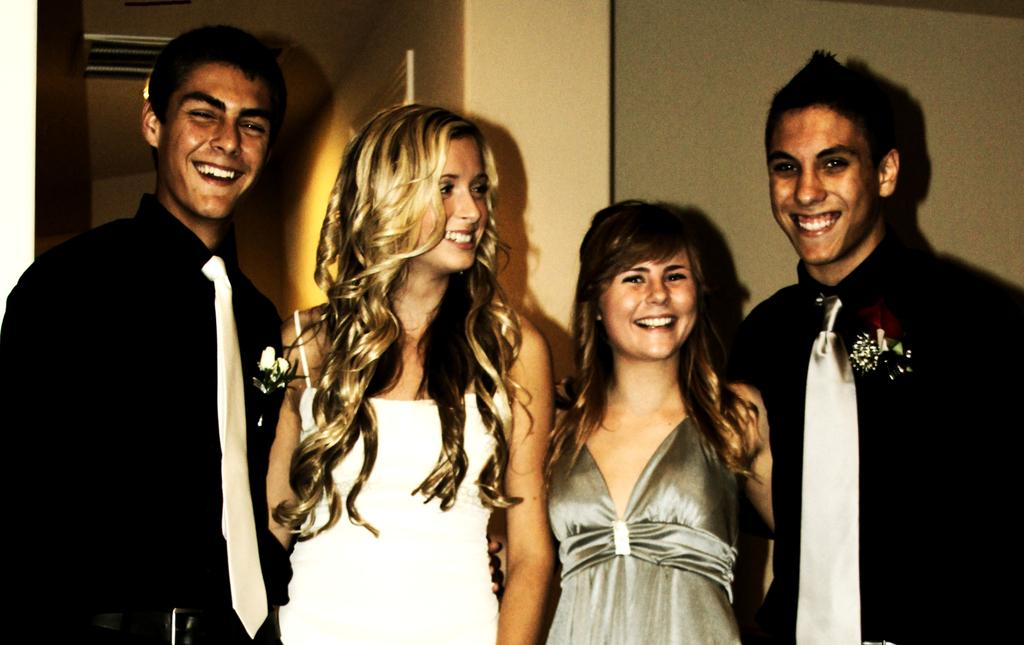How many people are present in the image? There are four people in the image, two men and two ladies. What are the people in the image doing? The people are standing. What can be seen in the background of the image? There is a wall in the background of the image. What type of pin can be seen holding the group together in the image? There is no pin present in the image, and the people are not physically connected. 